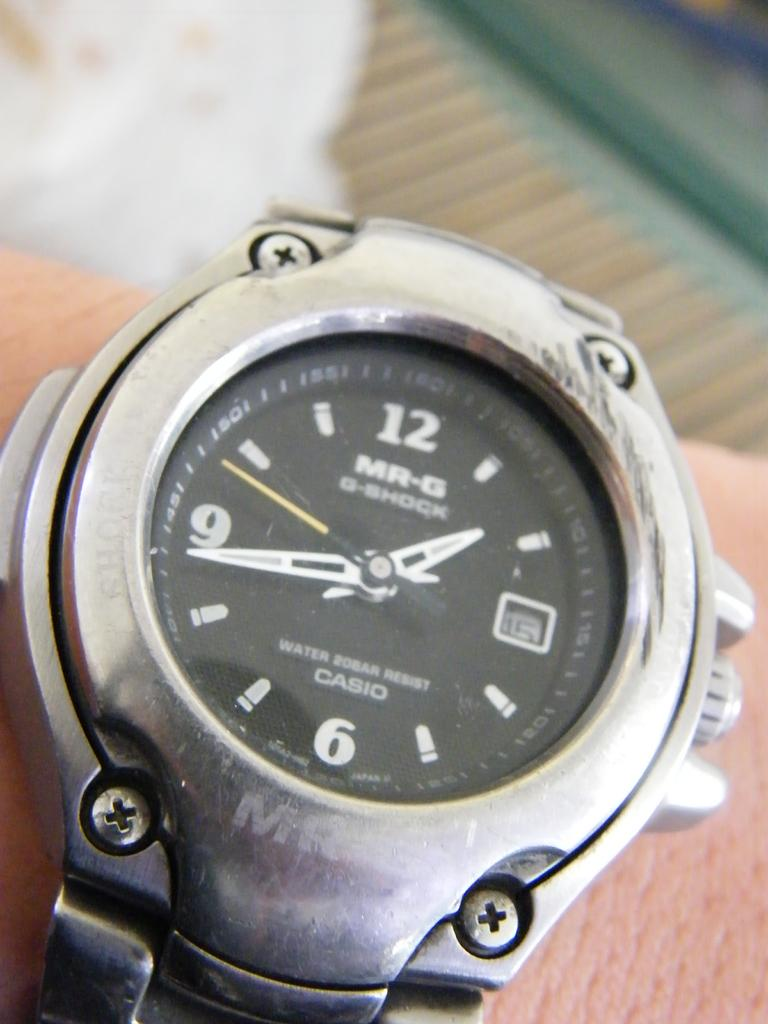Provide a one-sentence caption for the provided image. Person wearing a watch which has a black face and the word CASIO on it. 